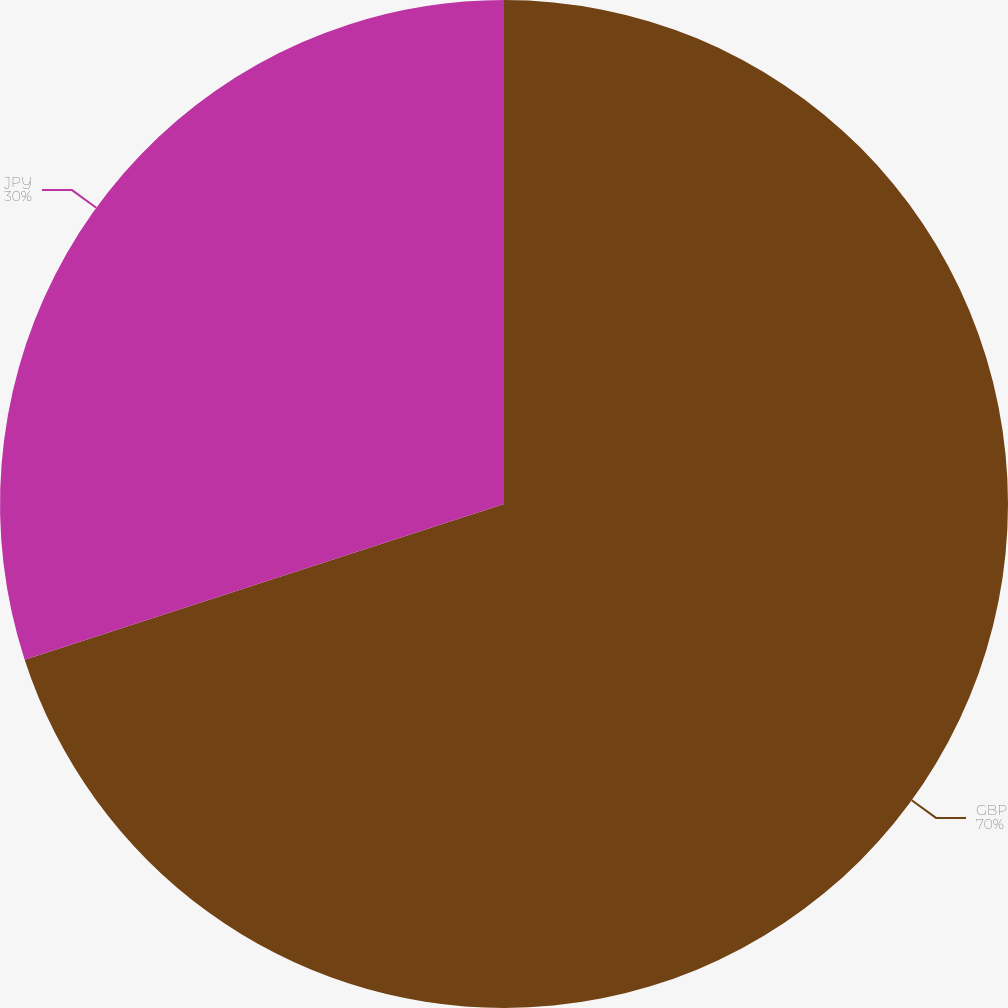Convert chart to OTSL. <chart><loc_0><loc_0><loc_500><loc_500><pie_chart><fcel>GBP<fcel>JPY<nl><fcel>70.0%<fcel>30.0%<nl></chart> 